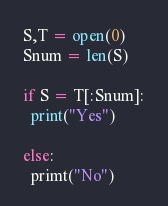<code> <loc_0><loc_0><loc_500><loc_500><_Python_>S,T = open(0)
Snum = len(S)

if S = T[:Snum]:
  print("Yes")
  
else:
  primt("No")</code> 